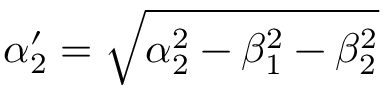<formula> <loc_0><loc_0><loc_500><loc_500>\alpha _ { 2 } ^ { \prime } = \sqrt { \alpha _ { 2 } ^ { 2 } - \beta _ { 1 } ^ { 2 } - \beta _ { 2 } ^ { 2 } }</formula> 